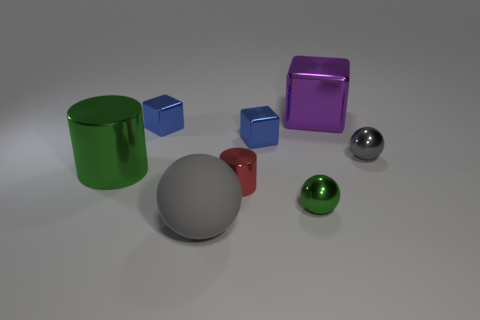Subtract all large cubes. How many cubes are left? 2 Subtract all blue spheres. How many blue blocks are left? 2 Add 1 small yellow rubber cubes. How many objects exist? 9 Subtract all cylinders. How many objects are left? 6 Subtract all red blocks. Subtract all yellow cylinders. How many blocks are left? 3 Add 5 blocks. How many blocks are left? 8 Add 4 small red objects. How many small red objects exist? 5 Subtract 0 purple balls. How many objects are left? 8 Subtract 2 cylinders. How many cylinders are left? 0 Subtract all big purple things. Subtract all large metallic objects. How many objects are left? 5 